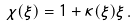<formula> <loc_0><loc_0><loc_500><loc_500>\chi ( \xi ) = 1 + \kappa ( \xi ) \xi \, .</formula> 